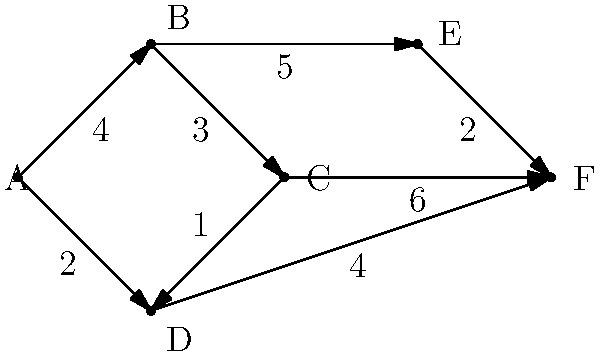As a committee member organizing a conference on graph theory algorithms, you need to create a practical example for a workshop on shortest path algorithms. Using the weighted directed graph provided, what is the shortest path from node A to node F, and what is its total weight? This example will be used to demonstrate Dijkstra's algorithm during the workshop. To find the shortest path from A to F using Dijkstra's algorithm, we follow these steps:

1. Initialize:
   - Set distance to A as 0, all others as infinity.
   - Set all nodes as unvisited.
   - Set A as the current node.

2. For the current node, consider all unvisited neighbors and calculate their tentative distances:
   - A to B: 4
   - A to D: 2
   Update D as it has the shorter distance.

3. Mark A as visited. Set D as the current node.

4. From D, consider unvisited neighbors:
   - D to C: 2 + 1 = 3
   - D to F: 2 + 4 = 6
   Update both C and F.

5. Mark D as visited. Set C as the current node (shortest known distance).

6. From C, consider unvisited neighbors:
   - C to B: 3 + 3 = 6 (not shorter than current B)
   - C to F: 3 + 6 = 9 (not shorter than current F)

7. Mark C as visited. Set F as the current node (shortest known distance among unvisited).

8. All paths to F are now explored. The algorithm ends.

The shortest path is A → D → F with a total weight of 6.
Answer: A → D → F, total weight 6 